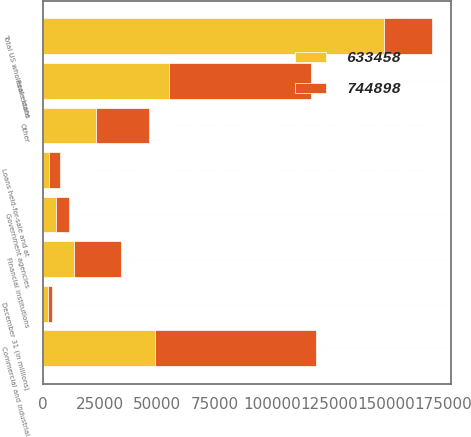Convert chart to OTSL. <chart><loc_0><loc_0><loc_500><loc_500><stacked_bar_chart><ecel><fcel>December 31 (in millions)<fcel>Commercial and industrial<fcel>Real estate<fcel>Financial institutions<fcel>Government agencies<fcel>Other<fcel>Loans held-for-sale and at<fcel>Total US wholesale loans<nl><fcel>633458<fcel>2009<fcel>49103<fcel>54968<fcel>13372<fcel>5634<fcel>23383<fcel>2625<fcel>149085<nl><fcel>744898<fcel>2008<fcel>70208<fcel>61888<fcel>20615<fcel>5918<fcel>23157<fcel>4990<fcel>20615<nl></chart> 